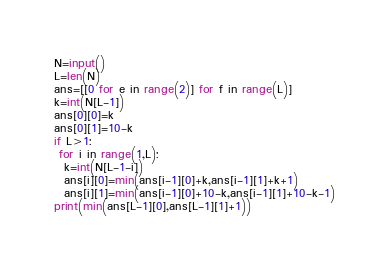<code> <loc_0><loc_0><loc_500><loc_500><_Python_>N=input()
L=len(N)
ans=[[0 for e in range(2)] for f in range(L)]
k=int(N[L-1])
ans[0][0]=k
ans[0][1]=10-k
if L>1:
 for i in range(1,L):
  k=int(N[L-1-i])
  ans[i][0]=min(ans[i-1][0]+k,ans[i-1][1]+k+1)
  ans[i][1]=min(ans[i-1][0]+10-k,ans[i-1][1]+10-k-1)
print(min(ans[L-1][0],ans[L-1][1]+1))
</code> 